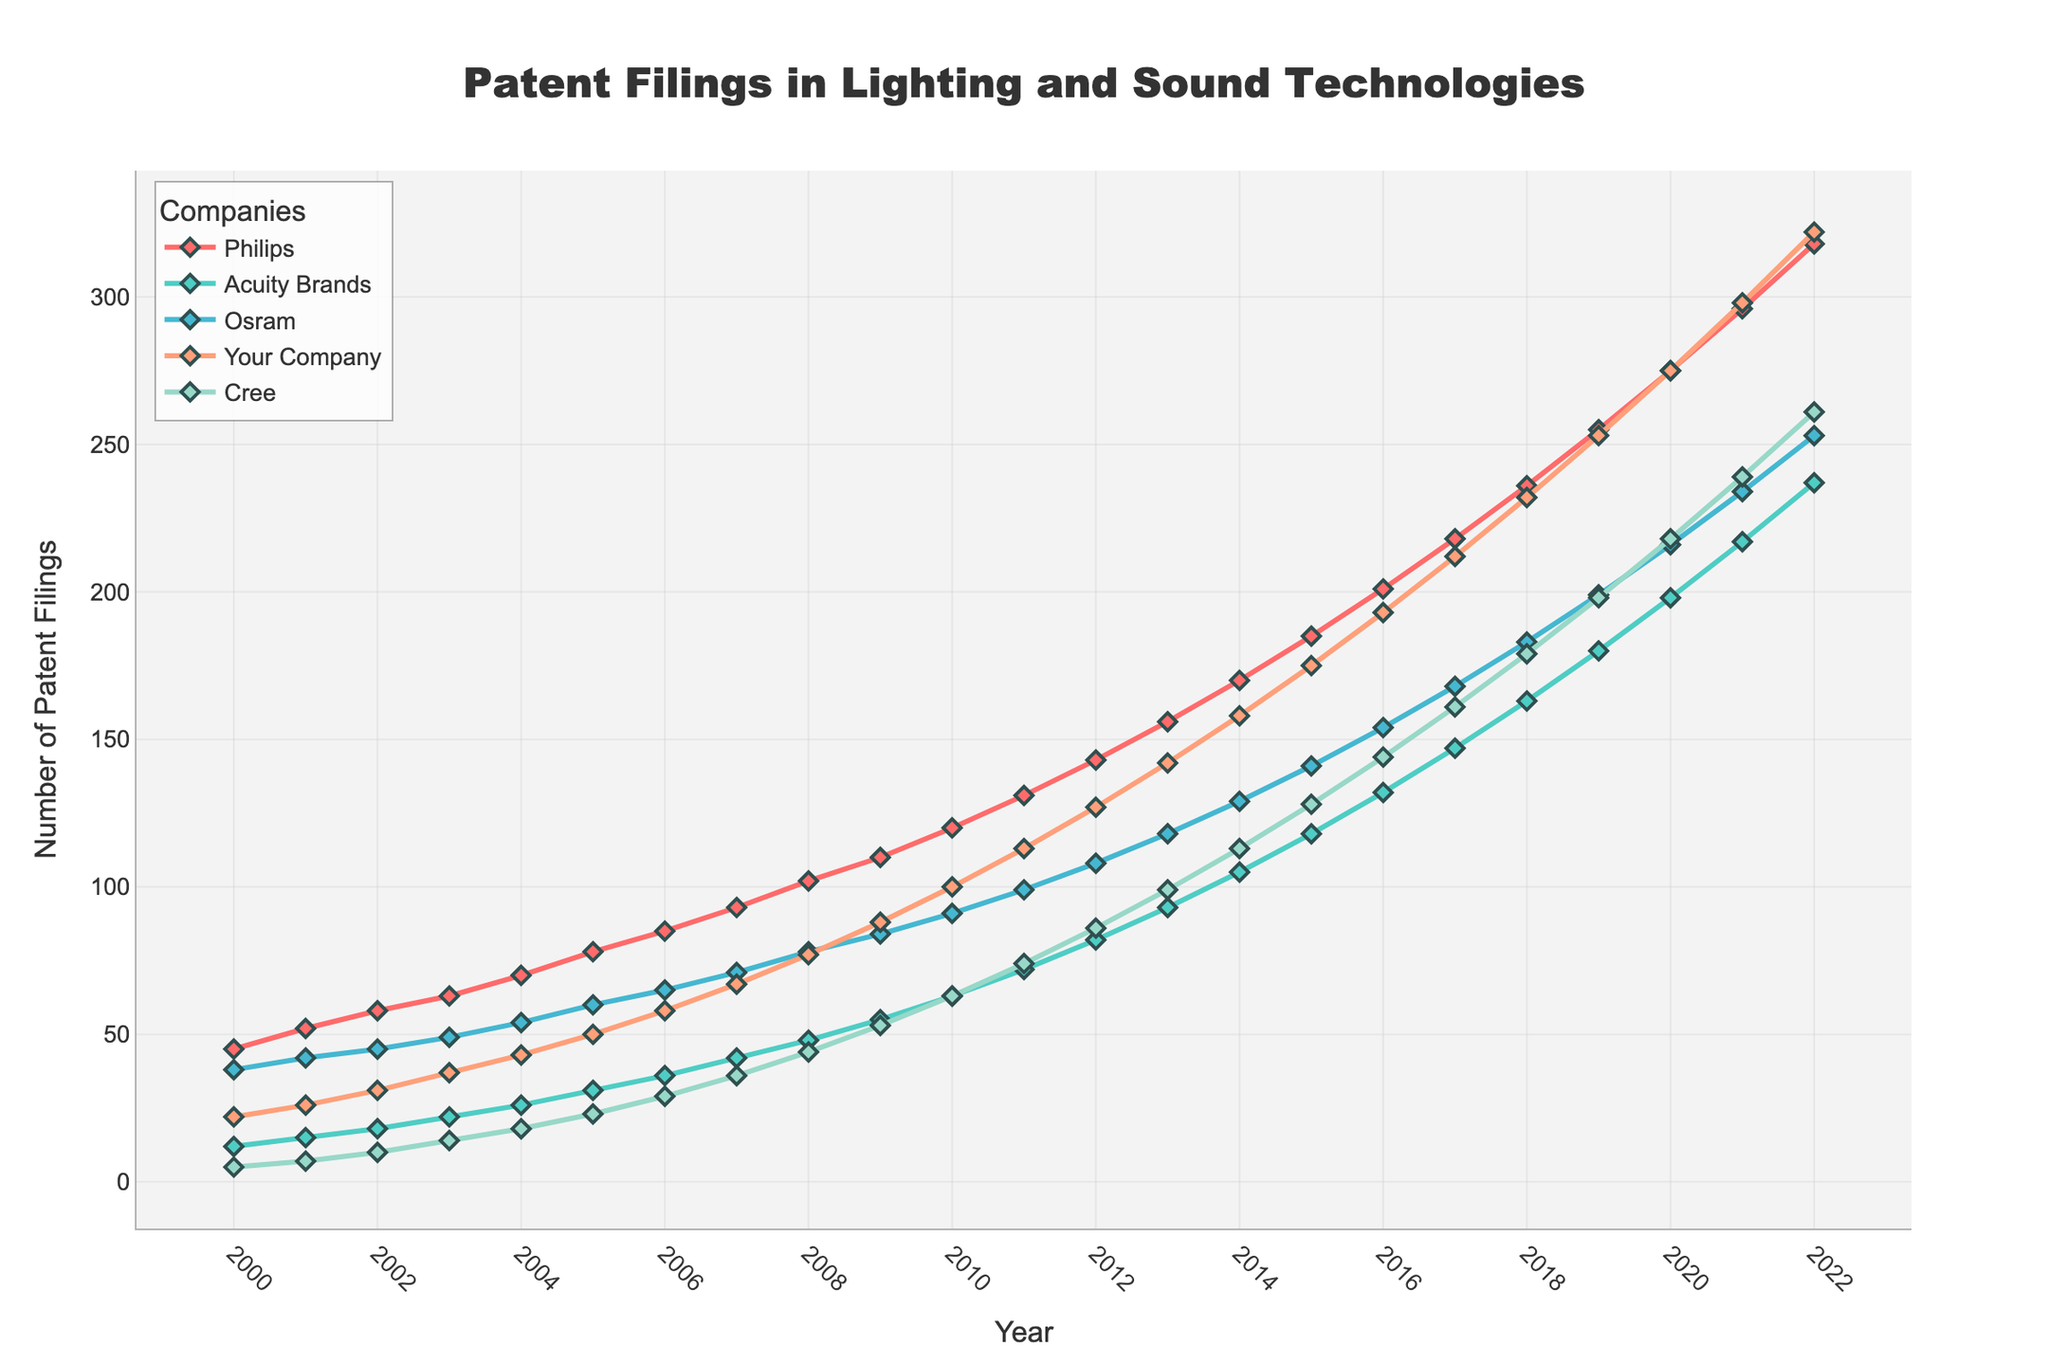Which company had the highest number of patent filings in 2020? The figure shows the number of patent filings for each company by year. In 2020, Philips had the highest number of patent filings.
Answer: Philips Between 2015 and 2020, did your company witness a greater increase in patents than Osram? Subtract the number of patents in 2015 from 2020 for both companies. For your company: 275 - 175 = 100. For Osram: 216 - 141 = 75. Your company had a greater increase.
Answer: Yes Which company had a consistent increase in patent filings every year from 2000 to 2022? Examine the trend lines for each company. Philips is the only company with a consistent increase in patent filings every year from 2000 to 2022.
Answer: Philips In which year did Philips surpass 150 patent filings? The figure shows Philips’ patents crossing the 150 marks in 2013 as they have 156 filings in that year.
Answer: 2013 What is the difference in the number of patent filings between the top performer and the least performer in 2022? The top performer in 2022 is Philips with 318 filings and the least is Cree with 261. The difference is 318 - 261 = 57.
Answer: 57 Which company has shown the most rapid increase in patent filings after 2016? Comparing the slopes of each line after 2016, Philips’ line is the steepest, indicating a rapid increase in patent filings.
Answer: Philips How many total patent filings did Philips and your company have combined in 2010? Add the patent filings of Philips (120) and your company (100) for 2010. 120 + 100 = 220.
Answer: 220 What is the average number of patent filings by Acuity Brands between 2000 and 2022? Sum the patent filings for Acuity Brands from 2000 to 2022 and divide by the number of years (23). (12 + 15 + ... + 217 + 237) / 23. The total sum is 2378. 2378 / 23 = 103.4.
Answer: 103.4 Did any company file fewer patents than your company in any year from 2000 to 2022? By examining the graph, it is evident that Cree filed fewer patents than your company from 2000 to around 2007.
Answer: Yes 